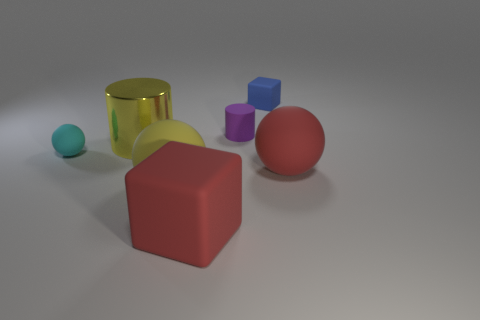Is the material of the purple thing to the left of the tiny blue rubber block the same as the yellow cylinder?
Provide a short and direct response. No. How many large red objects are the same shape as the cyan rubber object?
Your answer should be compact. 1. What number of small things are yellow shiny cylinders or yellow things?
Make the answer very short. 0. There is a large matte sphere that is to the right of the small blue thing; does it have the same color as the big rubber block?
Offer a very short reply. Yes. There is a big ball in front of the large red ball; does it have the same color as the big cylinder to the left of the red block?
Make the answer very short. Yes. Is there a tiny yellow sphere that has the same material as the big yellow sphere?
Offer a terse response. No. How many yellow objects are tiny cubes or rubber cubes?
Offer a terse response. 0. Is the number of tiny things that are on the left side of the yellow shiny object greater than the number of big gray objects?
Provide a succinct answer. Yes. Do the purple matte thing and the red matte cube have the same size?
Provide a succinct answer. No. There is a small cylinder that is made of the same material as the blue thing; what is its color?
Make the answer very short. Purple. 